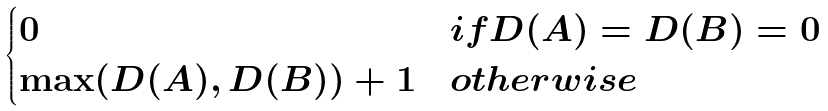<formula> <loc_0><loc_0><loc_500><loc_500>\begin{cases} 0 & i f D ( A ) = D ( B ) = 0 \\ \max ( D ( A ) , D ( B ) ) + 1 & o t h e r w i s e \end{cases}</formula> 